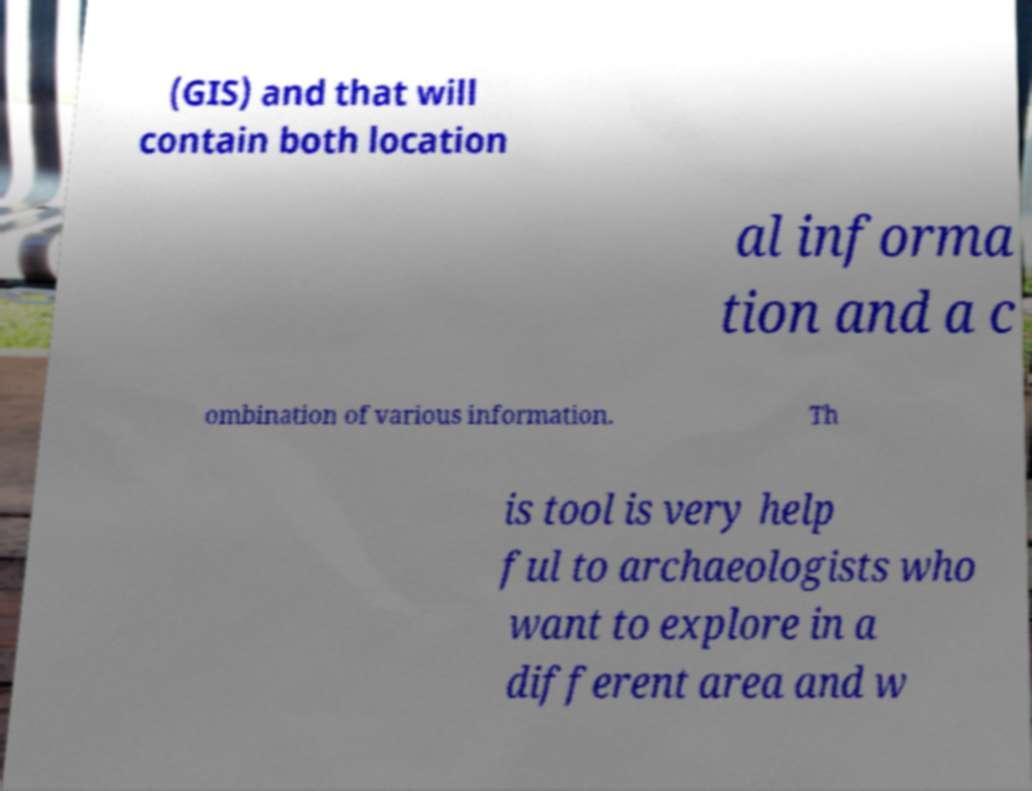Can you read and provide the text displayed in the image?This photo seems to have some interesting text. Can you extract and type it out for me? (GIS) and that will contain both location al informa tion and a c ombination of various information. Th is tool is very help ful to archaeologists who want to explore in a different area and w 